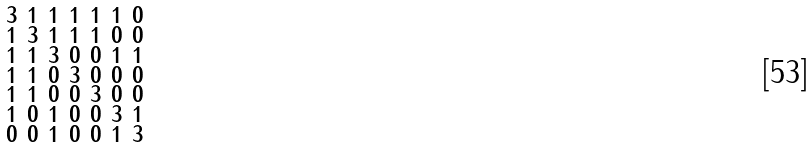Convert formula to latex. <formula><loc_0><loc_0><loc_500><loc_500>\begin{smallmatrix} 3 & 1 & 1 & 1 & 1 & 1 & 0 \\ 1 & 3 & 1 & 1 & 1 & 0 & 0 \\ 1 & 1 & 3 & 0 & 0 & 1 & 1 \\ 1 & 1 & 0 & 3 & 0 & 0 & 0 \\ 1 & 1 & 0 & 0 & 3 & 0 & 0 \\ 1 & 0 & 1 & 0 & 0 & 3 & 1 \\ 0 & 0 & 1 & 0 & 0 & 1 & 3 \end{smallmatrix}</formula> 